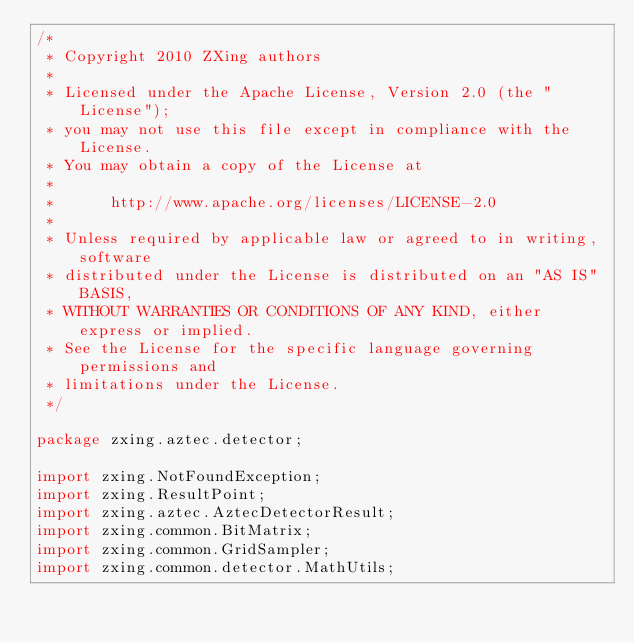<code> <loc_0><loc_0><loc_500><loc_500><_Java_>/*
 * Copyright 2010 ZXing authors
 *
 * Licensed under the Apache License, Version 2.0 (the "License");
 * you may not use this file except in compliance with the License.
 * You may obtain a copy of the License at
 *
 *      http://www.apache.org/licenses/LICENSE-2.0
 *
 * Unless required by applicable law or agreed to in writing, software
 * distributed under the License is distributed on an "AS IS" BASIS,
 * WITHOUT WARRANTIES OR CONDITIONS OF ANY KIND, either express or implied.
 * See the License for the specific language governing permissions and
 * limitations under the License.
 */

package zxing.aztec.detector;

import zxing.NotFoundException;
import zxing.ResultPoint;
import zxing.aztec.AztecDetectorResult;
import zxing.common.BitMatrix;
import zxing.common.GridSampler;
import zxing.common.detector.MathUtils;</code> 